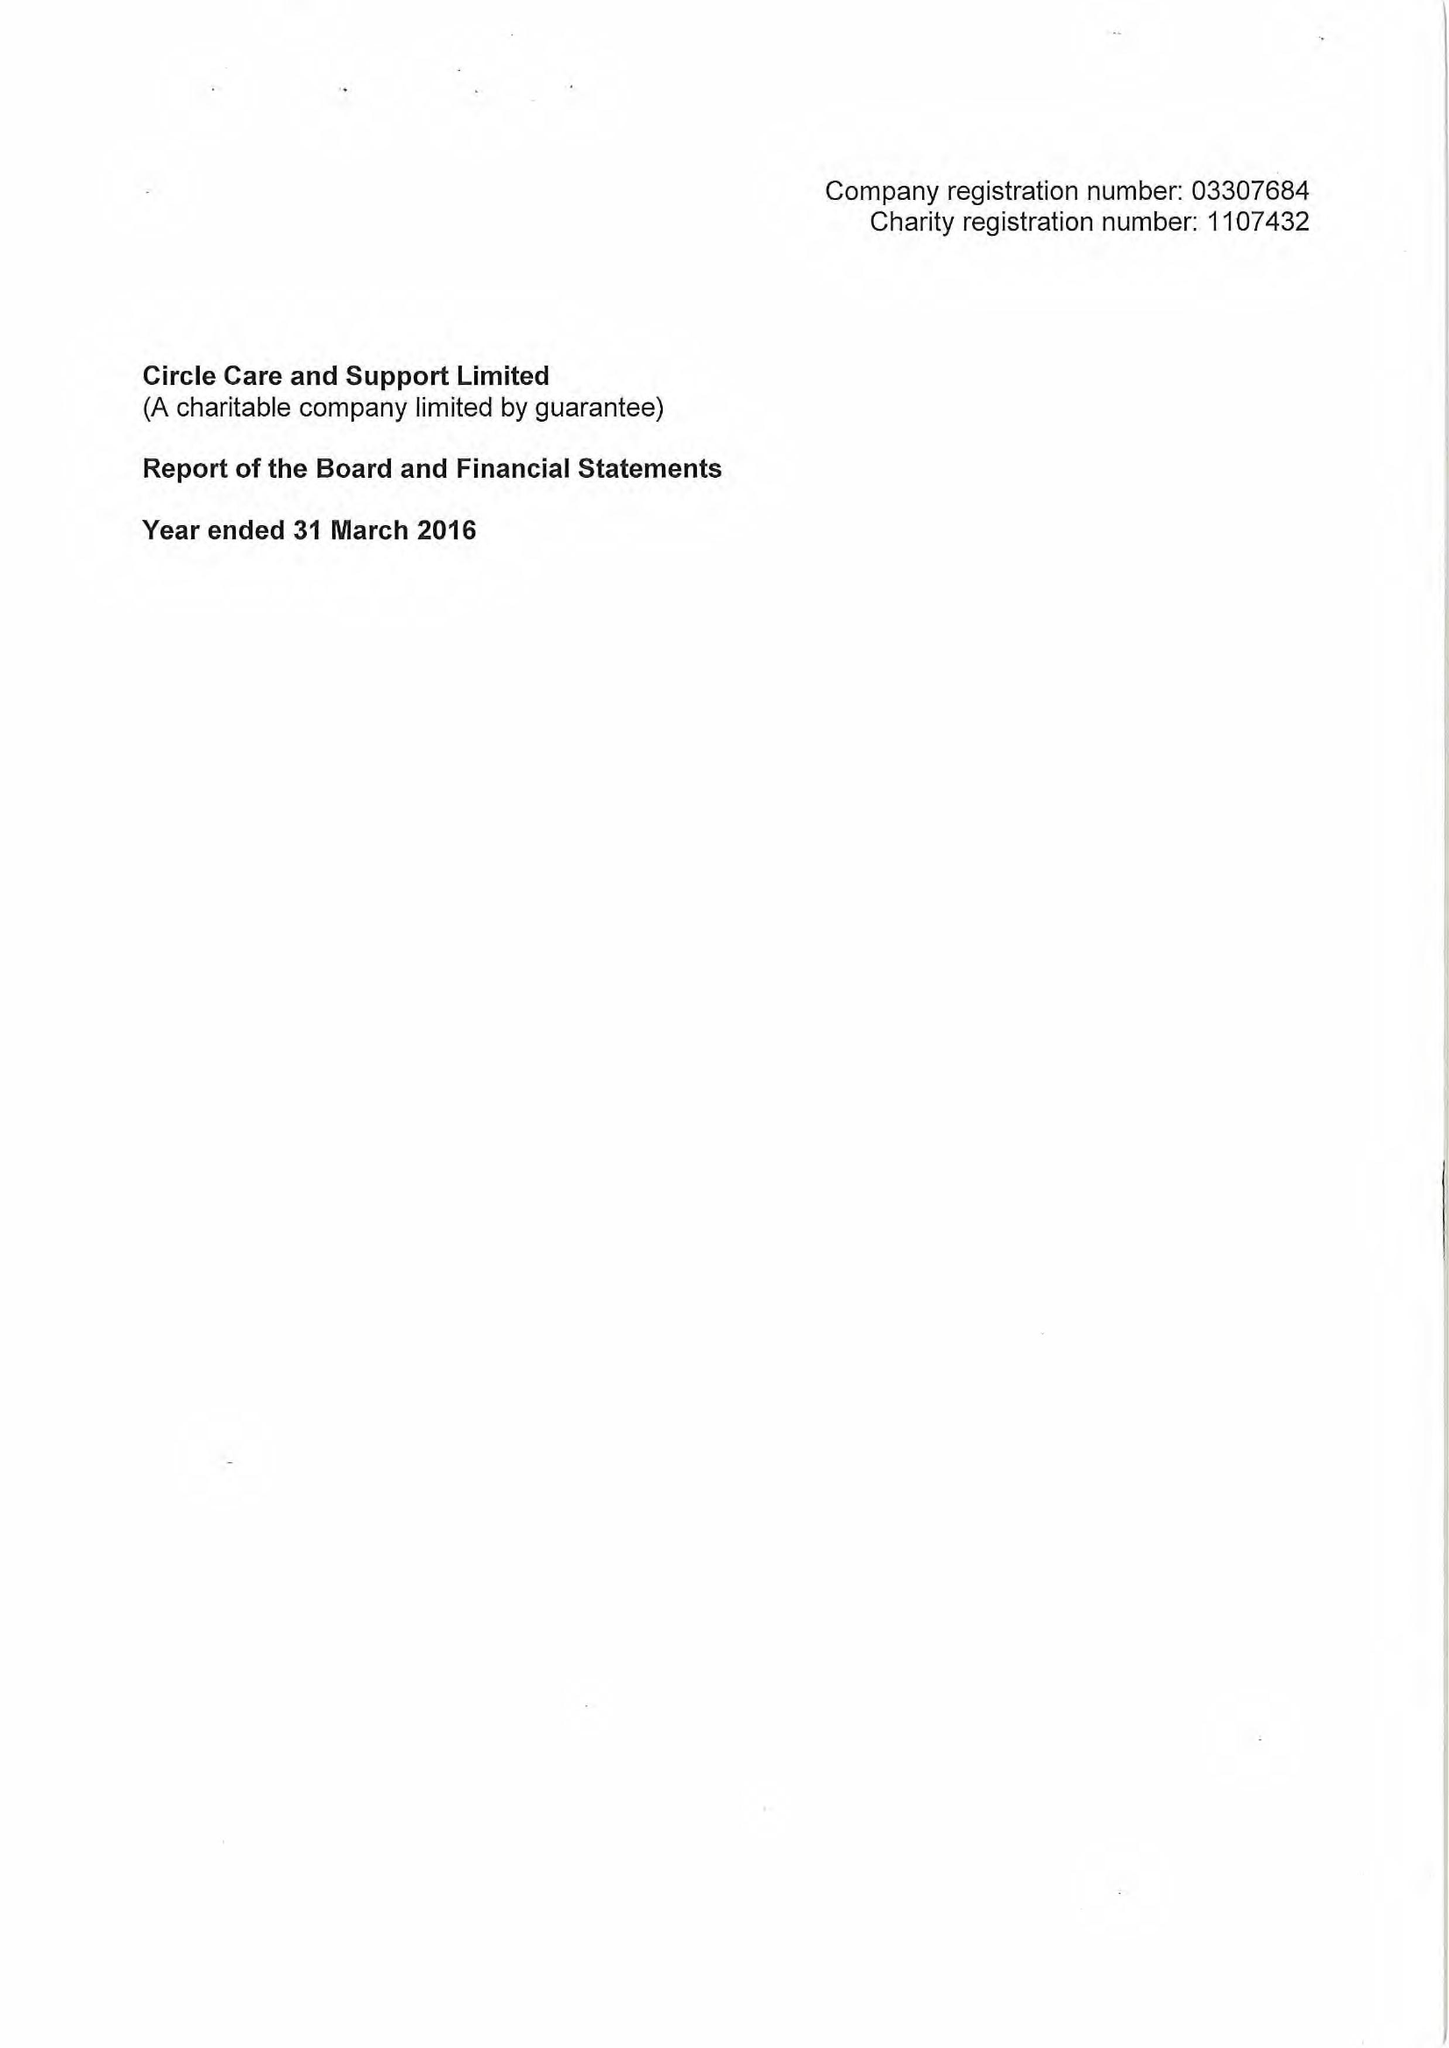What is the value for the charity_number?
Answer the question using a single word or phrase. 1107432 